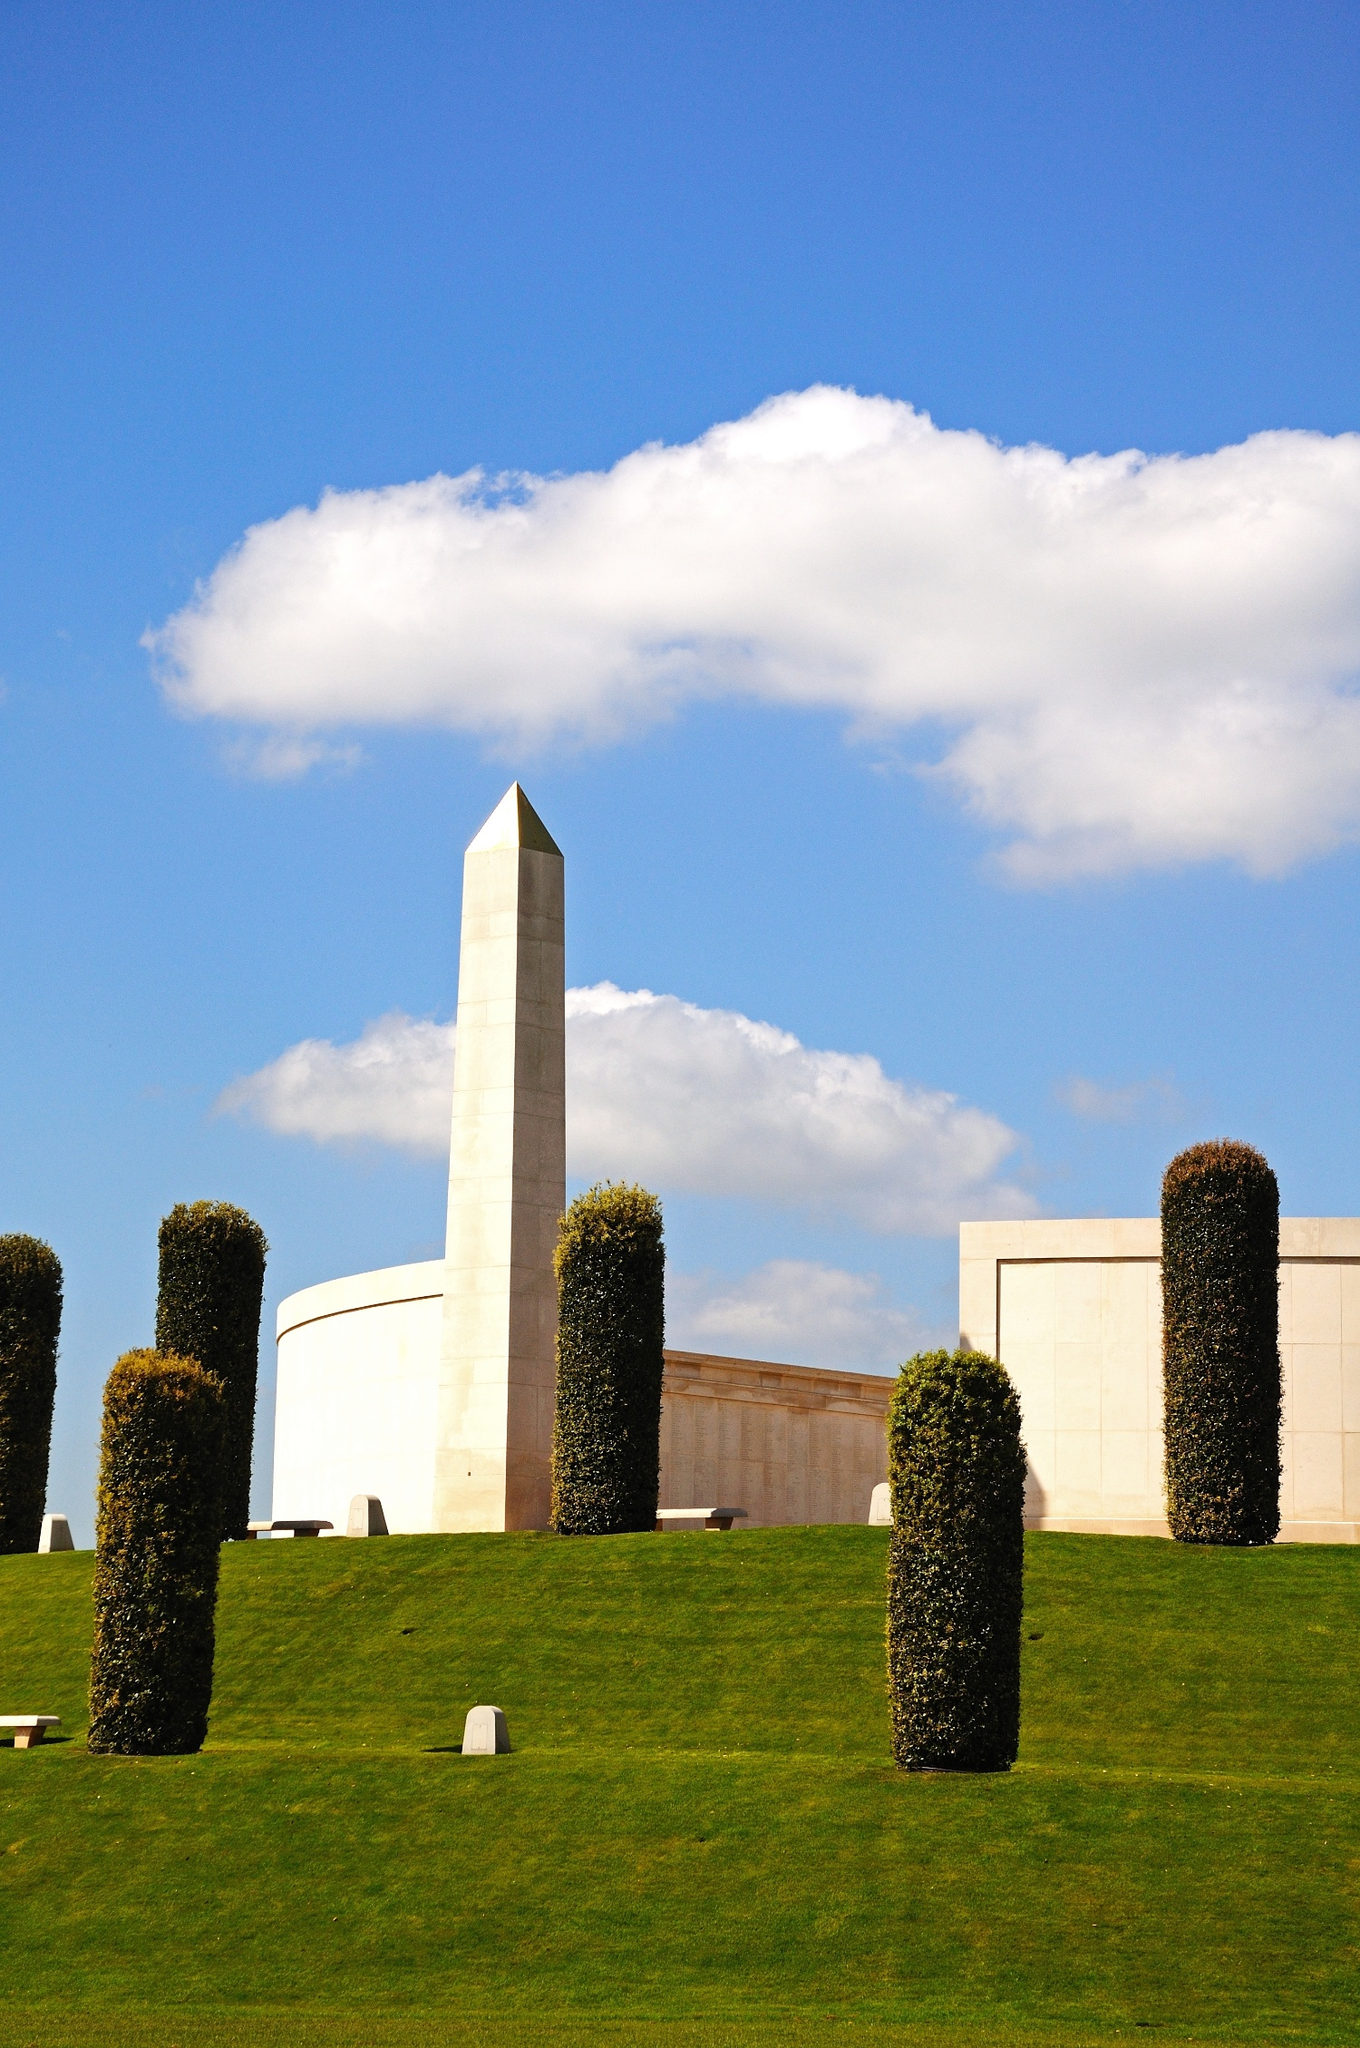Write a detailed description of the given image. The image showcases the National Memorial Arboretum in Staffordshire, UK. Captured from a low-angle perspective, the photograph highlights an impressive white stone obelisk that rises prominently against a beautifully clear blue sky. The sky is adorned with a few fluffy white clouds, enhancing the serene atmosphere. The lush green grass at the base of the obelisk is meticulously maintained and features several evenly spaced, neatly trimmed bushes. This careful landscaping complements the solemnity of the memorial. The stark white color of the obelisk stands in striking contrast to both the deep green of the lawn and the vibrant blue of the sky, emphasizing its significance as a place of remembrance and honor. Overall, the image exudes a peaceful and respectful ambiance, reflective of the site's purpose. 